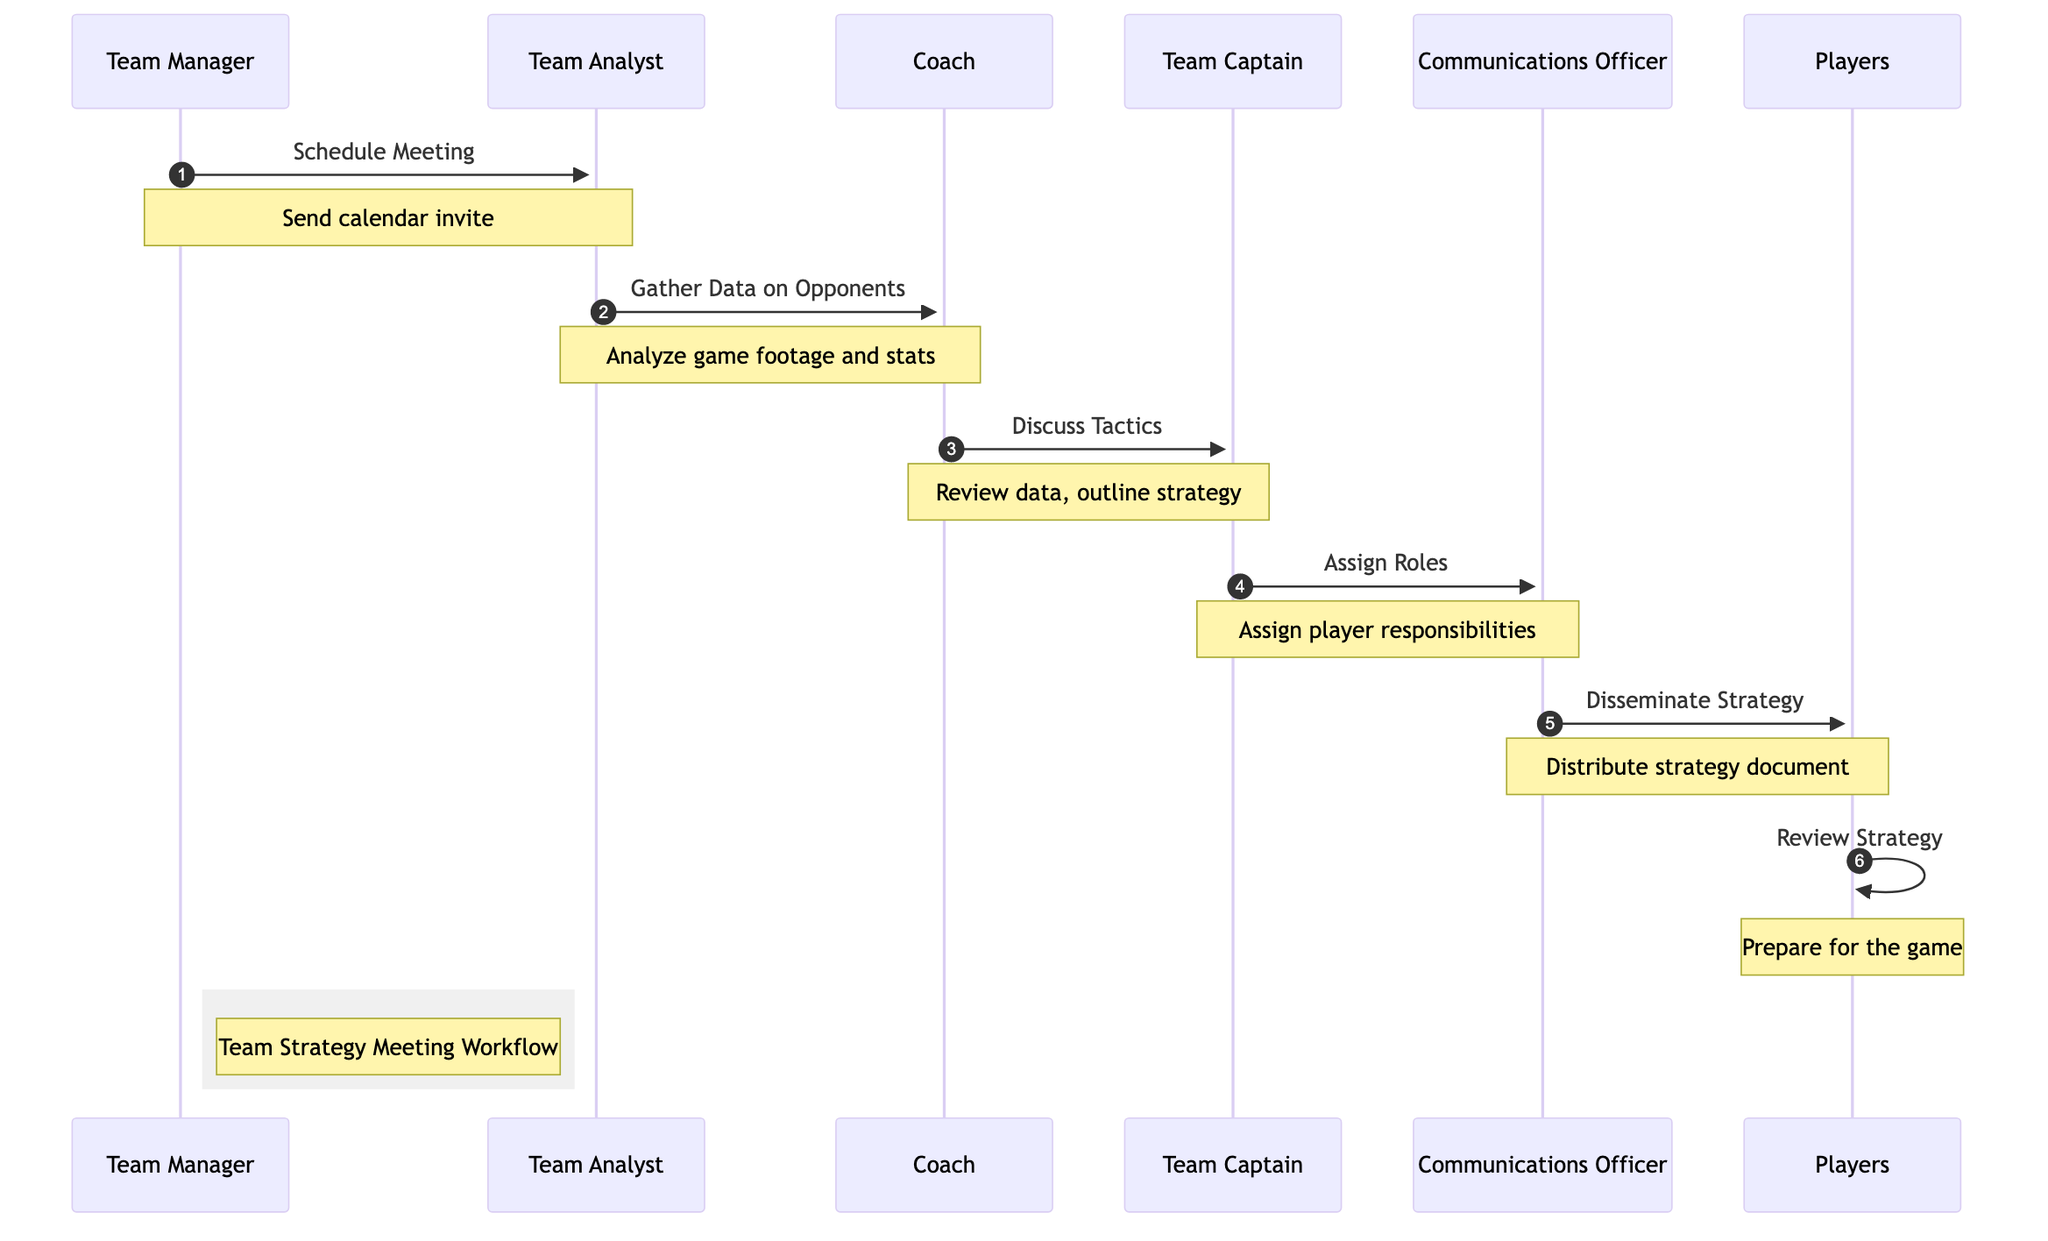What is the first action in the diagram? The first action in the sequence diagram is "Schedule Meeting," performed by the Team Manager. This action initiates the workflow by sending out a calendar invite.
Answer: Schedule Meeting How many participants are in the diagram? The diagram features six participants: Team Manager, Team Analyst, Coach, Team Captain, Communications Officer, and Players.
Answer: Six Who is responsible for gathering data on opponents? The Team Analyst is responsible for gathering data, which includes analyzing recent game footage and statistics of upcoming opponents.
Answer: Team Analyst What role does the Communications Officer have in the workflow? The Communications Officer's role is to disseminate the finalized strategy document to all team members after the roles have been assigned.
Answer: Disseminate Strategy Which action comes after discussing tactics? After discussing tactics, the next action is to assign roles, which is conducted by the Team Captain based on the outlined strategies.
Answer: Assign Roles How many actions are performed by players in the diagram? Players perform one action in the diagram, which is to review the strategy document and prepare for the game.
Answer: One What is the purpose of the "Discuss Tactics" action? The purpose of the "Discuss Tactics" action is to review the gathered data and outline the strengths and weaknesses of the opponents to establish an effective game plan.
Answer: Review data and outline strategy What note is associated with the Team Manager? The note associated with the Team Manager indicates that a calendar invite is sent to players and coaches to schedule the meeting, showing the initiation of the workflow.
Answer: Send calendar invite What description follows the action "Assign Roles"? The description following "Assign Roles" states that specific player roles and responsibilities are assigned based on the strategy developed during the meeting.
Answer: Assign specific player roles and responsibilities 